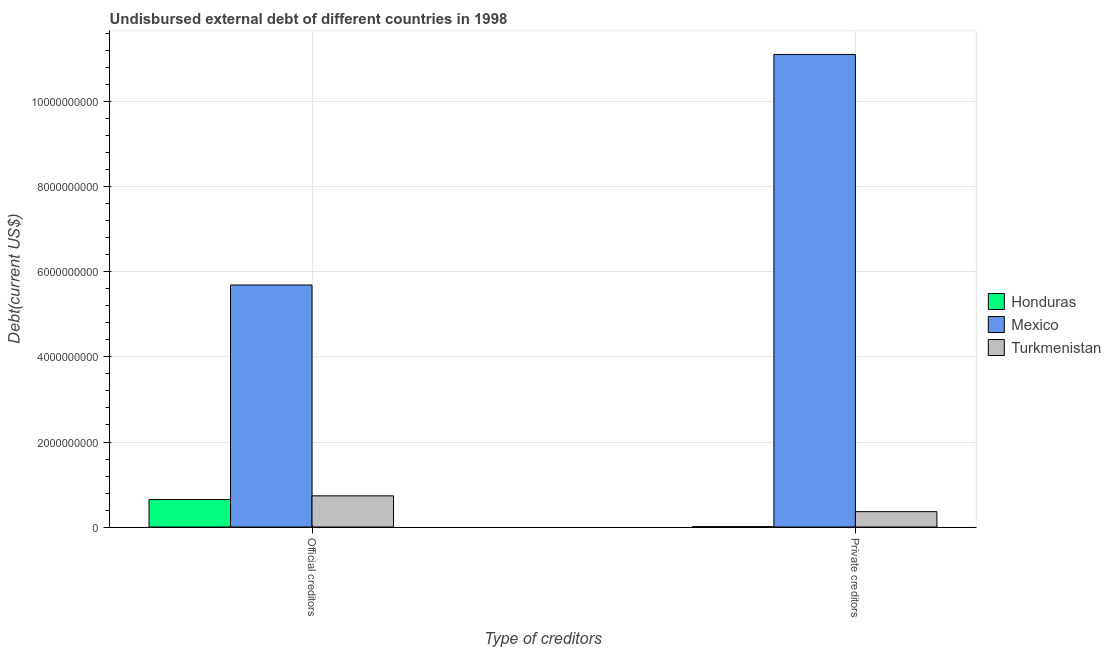Are the number of bars per tick equal to the number of legend labels?
Keep it short and to the point. Yes. Are the number of bars on each tick of the X-axis equal?
Give a very brief answer. Yes. How many bars are there on the 2nd tick from the right?
Offer a very short reply. 3. What is the label of the 1st group of bars from the left?
Your response must be concise. Official creditors. What is the undisbursed external debt of private creditors in Mexico?
Provide a short and direct response. 1.11e+1. Across all countries, what is the maximum undisbursed external debt of private creditors?
Provide a succinct answer. 1.11e+1. Across all countries, what is the minimum undisbursed external debt of private creditors?
Give a very brief answer. 8.00e+06. In which country was the undisbursed external debt of private creditors minimum?
Your response must be concise. Honduras. What is the total undisbursed external debt of official creditors in the graph?
Keep it short and to the point. 7.07e+09. What is the difference between the undisbursed external debt of private creditors in Turkmenistan and that in Mexico?
Keep it short and to the point. -1.08e+1. What is the difference between the undisbursed external debt of official creditors in Honduras and the undisbursed external debt of private creditors in Turkmenistan?
Provide a short and direct response. 2.84e+08. What is the average undisbursed external debt of private creditors per country?
Ensure brevity in your answer.  3.83e+09. What is the difference between the undisbursed external debt of private creditors and undisbursed external debt of official creditors in Honduras?
Your answer should be compact. -6.38e+08. In how many countries, is the undisbursed external debt of official creditors greater than 6000000000 US$?
Ensure brevity in your answer.  0. What is the ratio of the undisbursed external debt of official creditors in Honduras to that in Turkmenistan?
Your answer should be compact. 0.88. What does the 1st bar from the right in Official creditors represents?
Your response must be concise. Turkmenistan. Are all the bars in the graph horizontal?
Your response must be concise. No. What is the difference between two consecutive major ticks on the Y-axis?
Your answer should be compact. 2.00e+09. Does the graph contain any zero values?
Provide a short and direct response. No. How many legend labels are there?
Keep it short and to the point. 3. How are the legend labels stacked?
Your answer should be very brief. Vertical. What is the title of the graph?
Your response must be concise. Undisbursed external debt of different countries in 1998. Does "Bermuda" appear as one of the legend labels in the graph?
Provide a succinct answer. No. What is the label or title of the X-axis?
Provide a short and direct response. Type of creditors. What is the label or title of the Y-axis?
Offer a very short reply. Debt(current US$). What is the Debt(current US$) in Honduras in Official creditors?
Keep it short and to the point. 6.46e+08. What is the Debt(current US$) in Mexico in Official creditors?
Keep it short and to the point. 5.69e+09. What is the Debt(current US$) of Turkmenistan in Official creditors?
Your answer should be compact. 7.33e+08. What is the Debt(current US$) in Honduras in Private creditors?
Your answer should be very brief. 8.00e+06. What is the Debt(current US$) in Mexico in Private creditors?
Your answer should be very brief. 1.11e+1. What is the Debt(current US$) of Turkmenistan in Private creditors?
Your response must be concise. 3.62e+08. Across all Type of creditors, what is the maximum Debt(current US$) of Honduras?
Keep it short and to the point. 6.46e+08. Across all Type of creditors, what is the maximum Debt(current US$) of Mexico?
Provide a succinct answer. 1.11e+1. Across all Type of creditors, what is the maximum Debt(current US$) of Turkmenistan?
Your answer should be very brief. 7.33e+08. Across all Type of creditors, what is the minimum Debt(current US$) of Honduras?
Your answer should be compact. 8.00e+06. Across all Type of creditors, what is the minimum Debt(current US$) of Mexico?
Ensure brevity in your answer.  5.69e+09. Across all Type of creditors, what is the minimum Debt(current US$) in Turkmenistan?
Ensure brevity in your answer.  3.62e+08. What is the total Debt(current US$) of Honduras in the graph?
Provide a succinct answer. 6.54e+08. What is the total Debt(current US$) of Mexico in the graph?
Offer a very short reply. 1.68e+1. What is the total Debt(current US$) in Turkmenistan in the graph?
Your answer should be compact. 1.09e+09. What is the difference between the Debt(current US$) in Honduras in Official creditors and that in Private creditors?
Provide a succinct answer. 6.38e+08. What is the difference between the Debt(current US$) of Mexico in Official creditors and that in Private creditors?
Your answer should be compact. -5.42e+09. What is the difference between the Debt(current US$) in Turkmenistan in Official creditors and that in Private creditors?
Your answer should be very brief. 3.72e+08. What is the difference between the Debt(current US$) in Honduras in Official creditors and the Debt(current US$) in Mexico in Private creditors?
Make the answer very short. -1.05e+1. What is the difference between the Debt(current US$) of Honduras in Official creditors and the Debt(current US$) of Turkmenistan in Private creditors?
Provide a succinct answer. 2.84e+08. What is the difference between the Debt(current US$) of Mexico in Official creditors and the Debt(current US$) of Turkmenistan in Private creditors?
Your response must be concise. 5.33e+09. What is the average Debt(current US$) of Honduras per Type of creditors?
Your answer should be compact. 3.27e+08. What is the average Debt(current US$) of Mexico per Type of creditors?
Give a very brief answer. 8.41e+09. What is the average Debt(current US$) of Turkmenistan per Type of creditors?
Offer a very short reply. 5.47e+08. What is the difference between the Debt(current US$) of Honduras and Debt(current US$) of Mexico in Official creditors?
Provide a short and direct response. -5.05e+09. What is the difference between the Debt(current US$) in Honduras and Debt(current US$) in Turkmenistan in Official creditors?
Provide a succinct answer. -8.74e+07. What is the difference between the Debt(current US$) in Mexico and Debt(current US$) in Turkmenistan in Official creditors?
Ensure brevity in your answer.  4.96e+09. What is the difference between the Debt(current US$) in Honduras and Debt(current US$) in Mexico in Private creditors?
Offer a very short reply. -1.11e+1. What is the difference between the Debt(current US$) of Honduras and Debt(current US$) of Turkmenistan in Private creditors?
Offer a terse response. -3.54e+08. What is the difference between the Debt(current US$) in Mexico and Debt(current US$) in Turkmenistan in Private creditors?
Offer a very short reply. 1.08e+1. What is the ratio of the Debt(current US$) of Honduras in Official creditors to that in Private creditors?
Make the answer very short. 80.69. What is the ratio of the Debt(current US$) in Mexico in Official creditors to that in Private creditors?
Ensure brevity in your answer.  0.51. What is the ratio of the Debt(current US$) in Turkmenistan in Official creditors to that in Private creditors?
Your response must be concise. 2.03. What is the difference between the highest and the second highest Debt(current US$) of Honduras?
Keep it short and to the point. 6.38e+08. What is the difference between the highest and the second highest Debt(current US$) of Mexico?
Make the answer very short. 5.42e+09. What is the difference between the highest and the second highest Debt(current US$) in Turkmenistan?
Make the answer very short. 3.72e+08. What is the difference between the highest and the lowest Debt(current US$) of Honduras?
Give a very brief answer. 6.38e+08. What is the difference between the highest and the lowest Debt(current US$) of Mexico?
Make the answer very short. 5.42e+09. What is the difference between the highest and the lowest Debt(current US$) of Turkmenistan?
Offer a very short reply. 3.72e+08. 